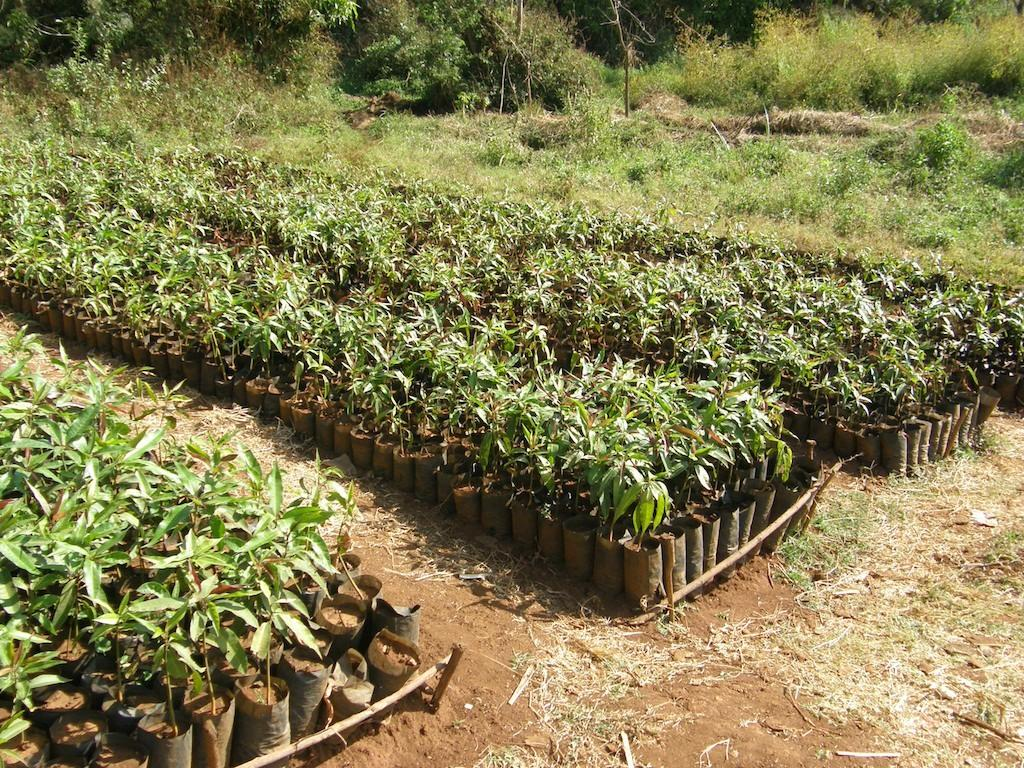What type of objects are holding plants in the image? There are pots with plants in the image. Where are the pots with plants located? The pots are placed on land. What type of vegetation can be seen on the land? There is grass and other plants on the land. What type of tall vegetation is visible in the image? There are trees in the image. What type of humor can be seen in the son's expression in the image? There is no son present in the image, and therefore no expression to analyze for humor. 